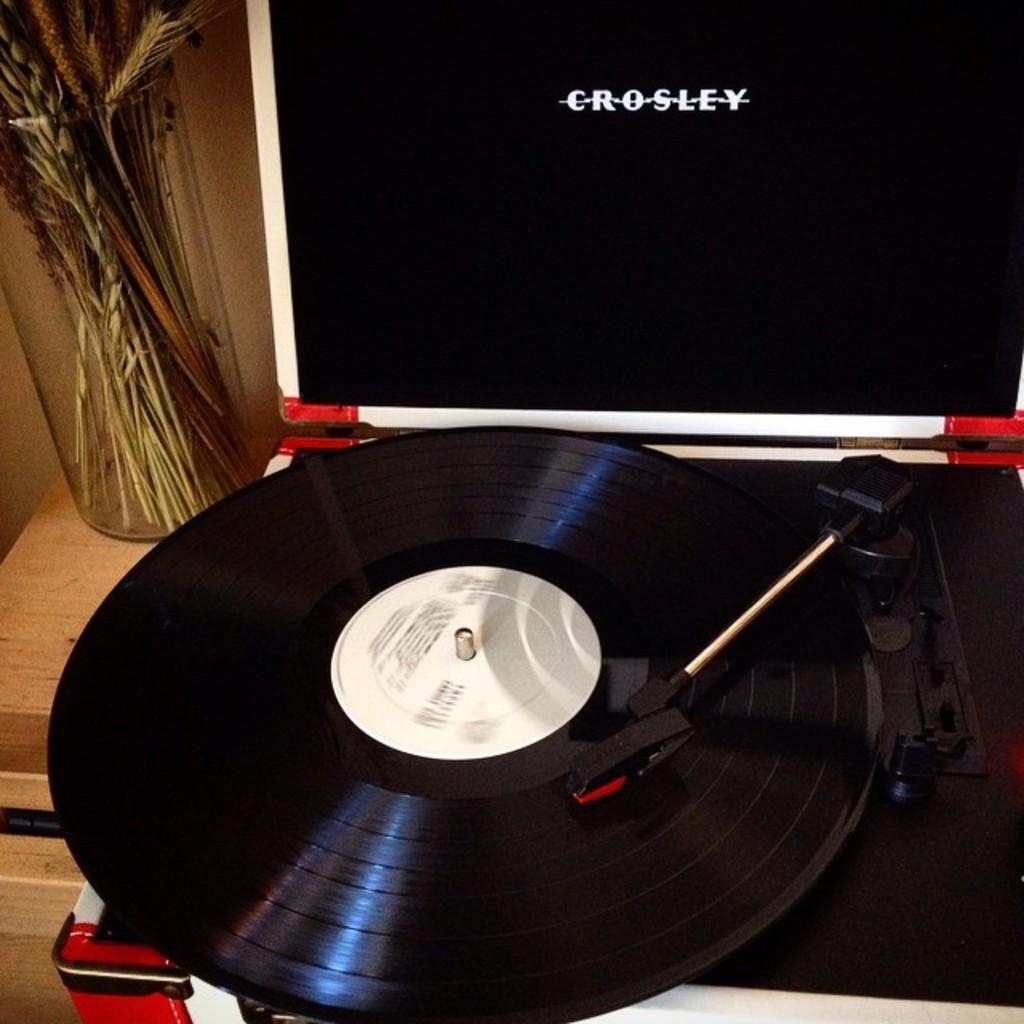What is the main object in the image? There is a deluxe gramophone in the image. What is the gramophone placed on? The gramophone is on a wooden surface. Are there any other objects near the gramophone? Yes, there is a flower vase beside the gramophone. What is the current time according to the clock in the image? There is no clock present in the image, so it is not possible to determine the current time. 